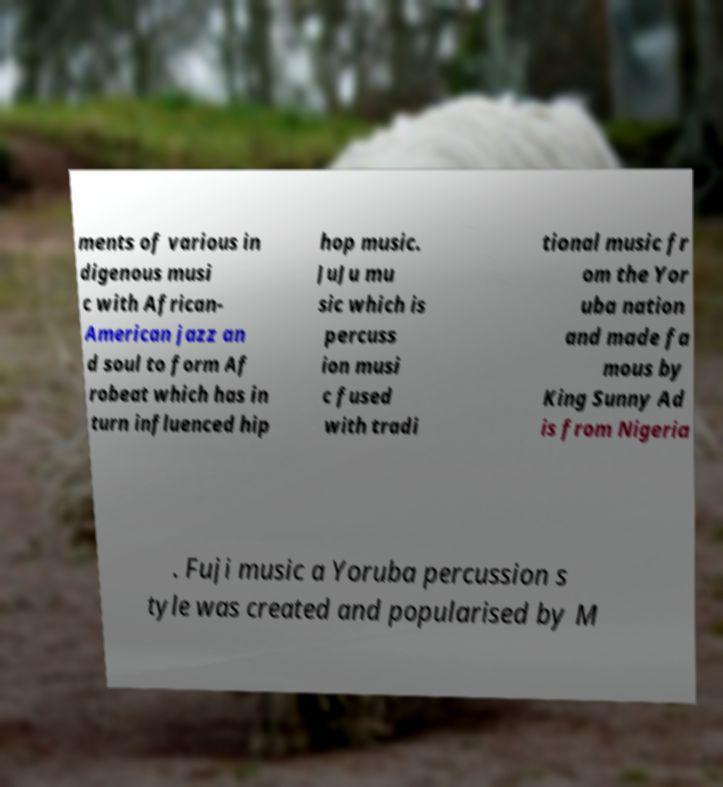What messages or text are displayed in this image? I need them in a readable, typed format. ments of various in digenous musi c with African- American jazz an d soul to form Af robeat which has in turn influenced hip hop music. JuJu mu sic which is percuss ion musi c fused with tradi tional music fr om the Yor uba nation and made fa mous by King Sunny Ad is from Nigeria . Fuji music a Yoruba percussion s tyle was created and popularised by M 